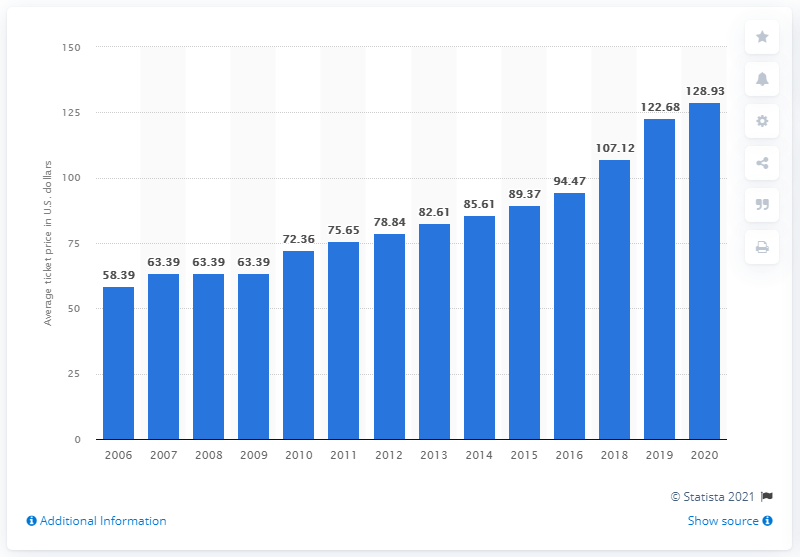Mention a couple of crucial points in this snapshot. The average ticket price for Green Bay Packers games in 2020 was $128.93. 